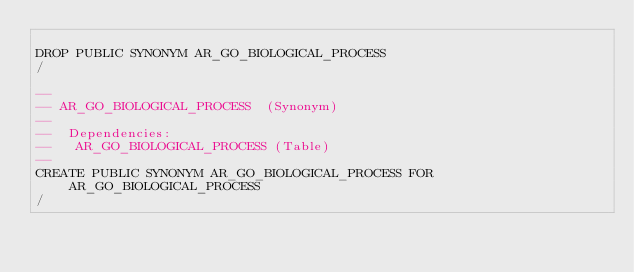Convert code to text. <code><loc_0><loc_0><loc_500><loc_500><_SQL_>
DROP PUBLIC SYNONYM AR_GO_BIOLOGICAL_PROCESS
/

--
-- AR_GO_BIOLOGICAL_PROCESS  (Synonym) 
--
--  Dependencies: 
--   AR_GO_BIOLOGICAL_PROCESS (Table)
--
CREATE PUBLIC SYNONYM AR_GO_BIOLOGICAL_PROCESS FOR AR_GO_BIOLOGICAL_PROCESS
/


</code> 